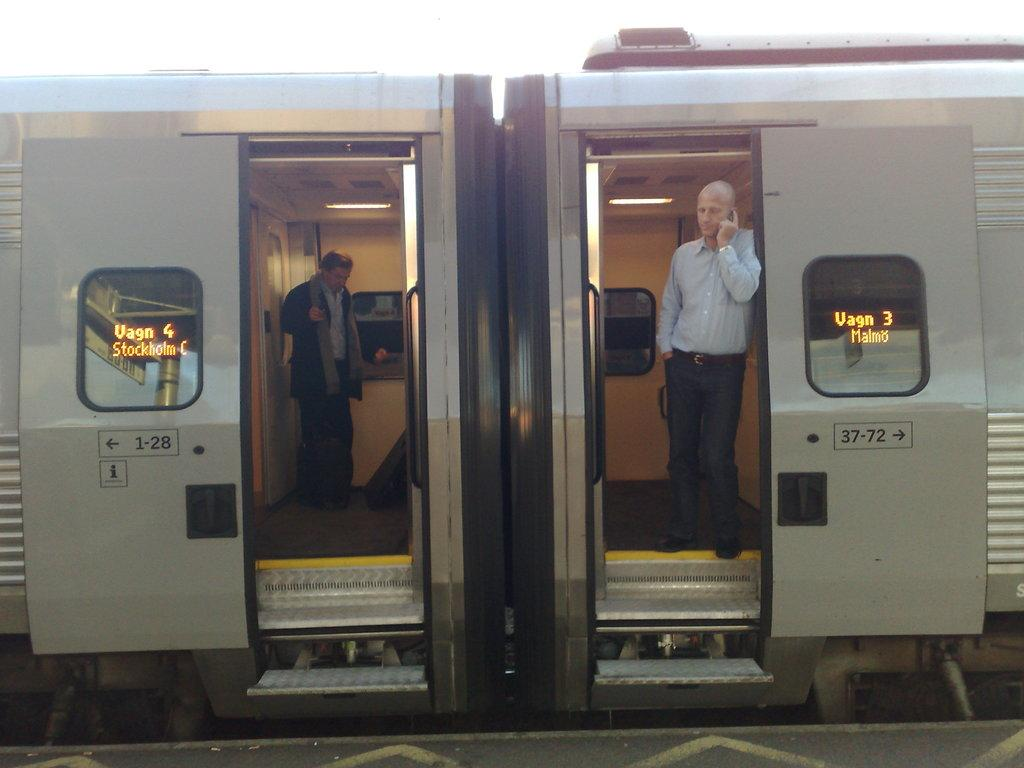How many people are in the vehicle in the image? There are two persons in the vehicle. What can be seen on the vehicle's windows? The vehicle has windows, but the image does not show any specific details about them. What type of markings are on the vehicle? There are numbers and arrow symbols on the vehicle. What type of relation does the vehicle have with the tax system? The image does not provide any information about the vehicle's relation to the tax system. What smell can be detected from the vehicle in the image? The image does not provide any information about the smell inside or around the vehicle. 